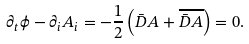<formula> <loc_0><loc_0><loc_500><loc_500>\partial _ { t } \phi - \partial _ { i } A _ { i } = - \frac { 1 } { 2 } \left ( \bar { D } A + \overline { \bar { D } A } \right ) = 0 .</formula> 